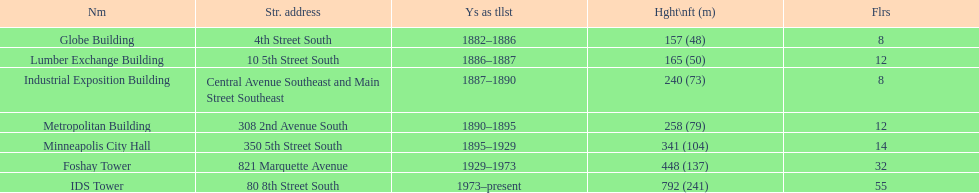Parse the full table in json format. {'header': ['Nm', 'Str. address', 'Ys as tllst', 'Hght\\nft (m)', 'Flrs'], 'rows': [['Globe Building', '4th Street South', '1882–1886', '157 (48)', '8'], ['Lumber Exchange Building', '10 5th Street South', '1886–1887', '165 (50)', '12'], ['Industrial Exposition Building', 'Central Avenue Southeast and Main Street Southeast', '1887–1890', '240 (73)', '8'], ['Metropolitan Building', '308 2nd Avenue South', '1890–1895', '258 (79)', '12'], ['Minneapolis City Hall', '350 5th Street South', '1895–1929', '341 (104)', '14'], ['Foshay Tower', '821 Marquette Avenue', '1929–1973', '448 (137)', '32'], ['IDS Tower', '80 8th Street South', '1973–present', '792 (241)', '55']]} What are the tallest buildings in minneapolis? Globe Building, Lumber Exchange Building, Industrial Exposition Building, Metropolitan Building, Minneapolis City Hall, Foshay Tower, IDS Tower. What is the height of the metropolitan building? 258 (79). What is the height of the lumber exchange building? 165 (50). Of those two which is taller? Metropolitan Building. 